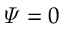<formula> <loc_0><loc_0><loc_500><loc_500>\varPsi = 0</formula> 